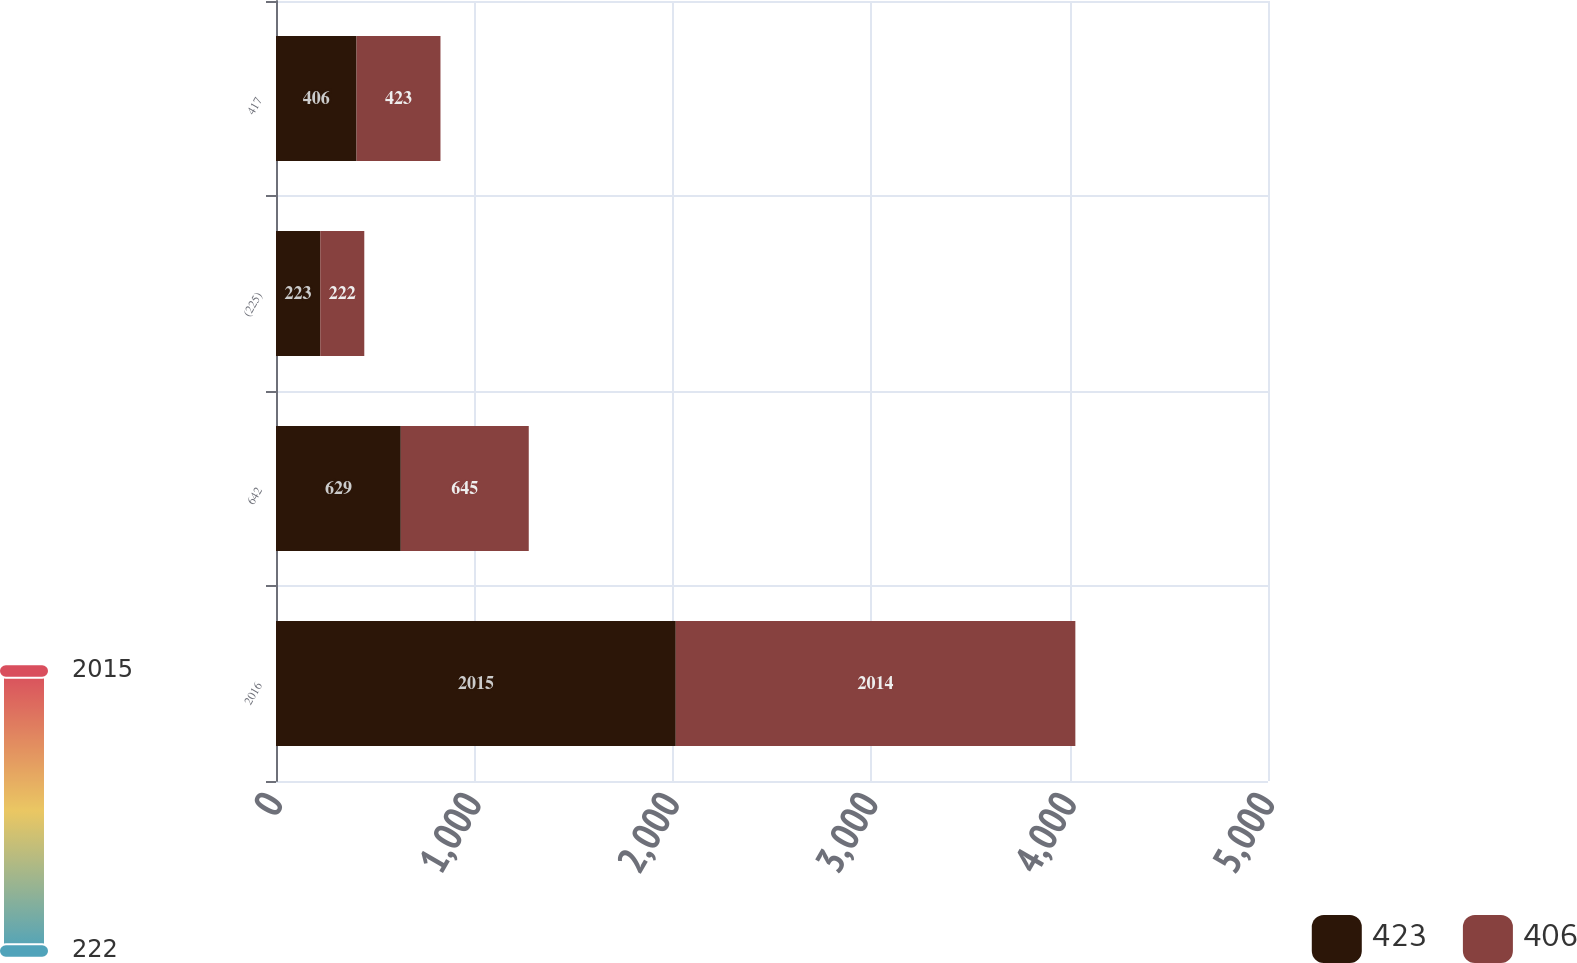Convert chart to OTSL. <chart><loc_0><loc_0><loc_500><loc_500><stacked_bar_chart><ecel><fcel>2016<fcel>642<fcel>(225)<fcel>417<nl><fcel>423<fcel>2015<fcel>629<fcel>223<fcel>406<nl><fcel>406<fcel>2014<fcel>645<fcel>222<fcel>423<nl></chart> 